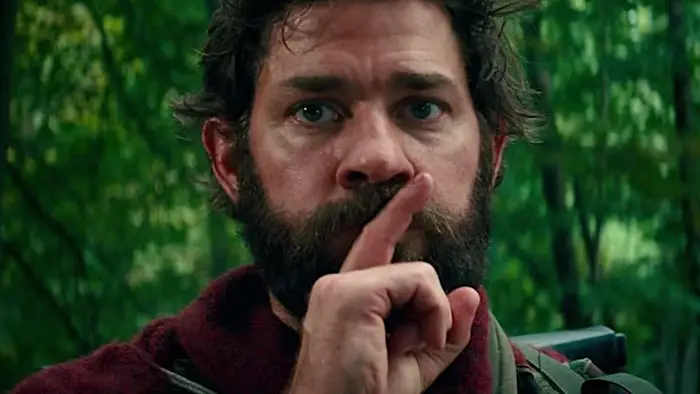Can you explain the significance of the red jacket in this image? The red jacket worn by the man stands out distinctly against the lush green background of the forest. This not only draws the viewer's attention directly to him, emphasizing his presence but might also suggest his boldness or a significant role in his environment, possibly as a leader or central figure in a narrative. 